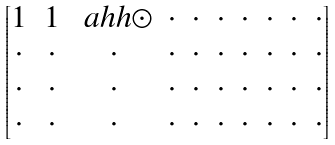<formula> <loc_0><loc_0><loc_500><loc_500>\begin{bmatrix} 1 & 1 & \ a h h { \odot } & \cdot & \cdot & \cdot & \cdot & \cdot & \cdot & \cdot \\ \cdot & \cdot & \cdot & \cdot & \cdot & \cdot & \cdot & \cdot & \cdot & \cdot \\ \cdot & \cdot & \cdot & \cdot & \cdot & \cdot & \cdot & \cdot & \cdot & \cdot \\ \cdot & \cdot & \cdot & \cdot & \cdot & \cdot & \cdot & \cdot & \cdot & \cdot \end{bmatrix}</formula> 